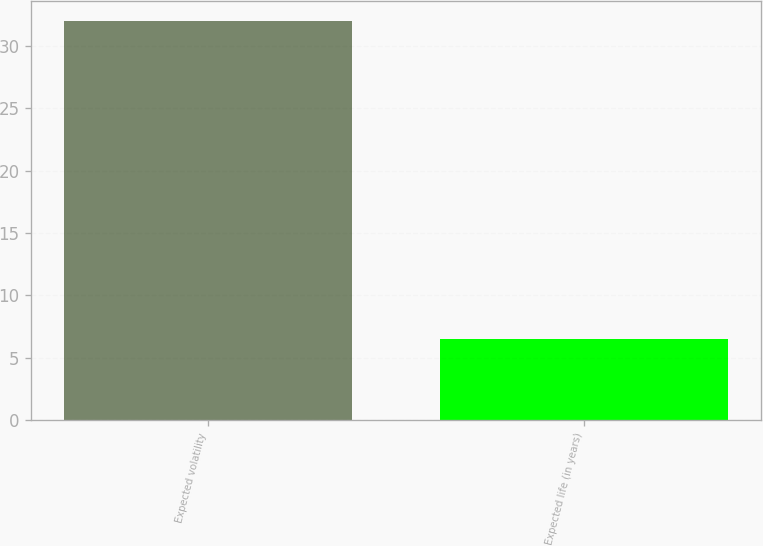Convert chart. <chart><loc_0><loc_0><loc_500><loc_500><bar_chart><fcel>Expected volatility<fcel>Expected life (in years)<nl><fcel>32<fcel>6.5<nl></chart> 